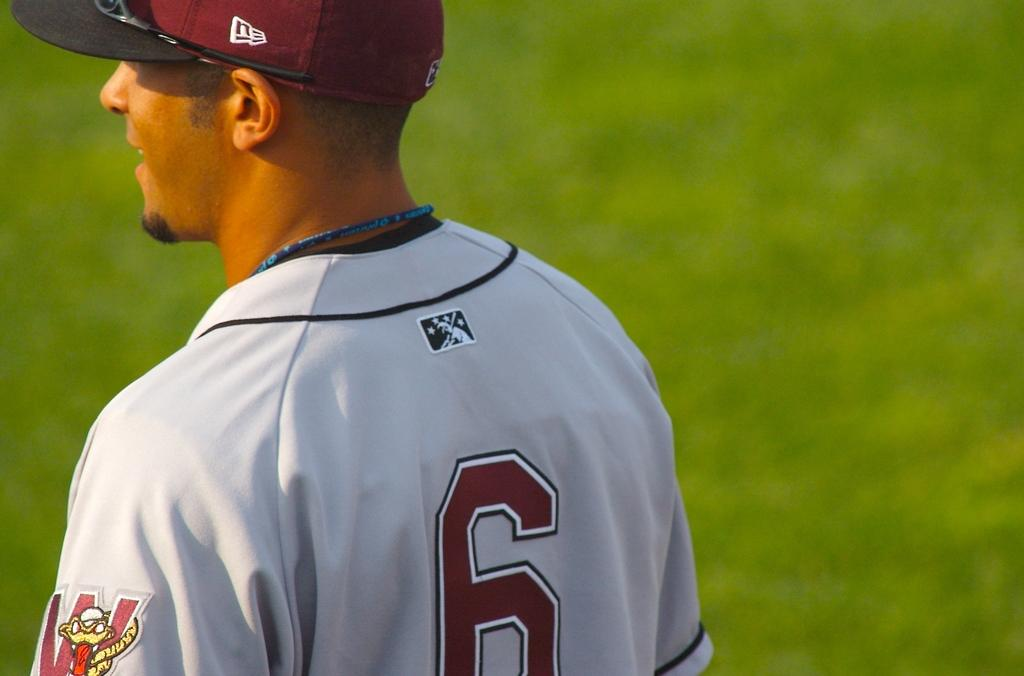<image>
Present a compact description of the photo's key features. Number 6 is wearing a baseball uniform and a new era hat. 